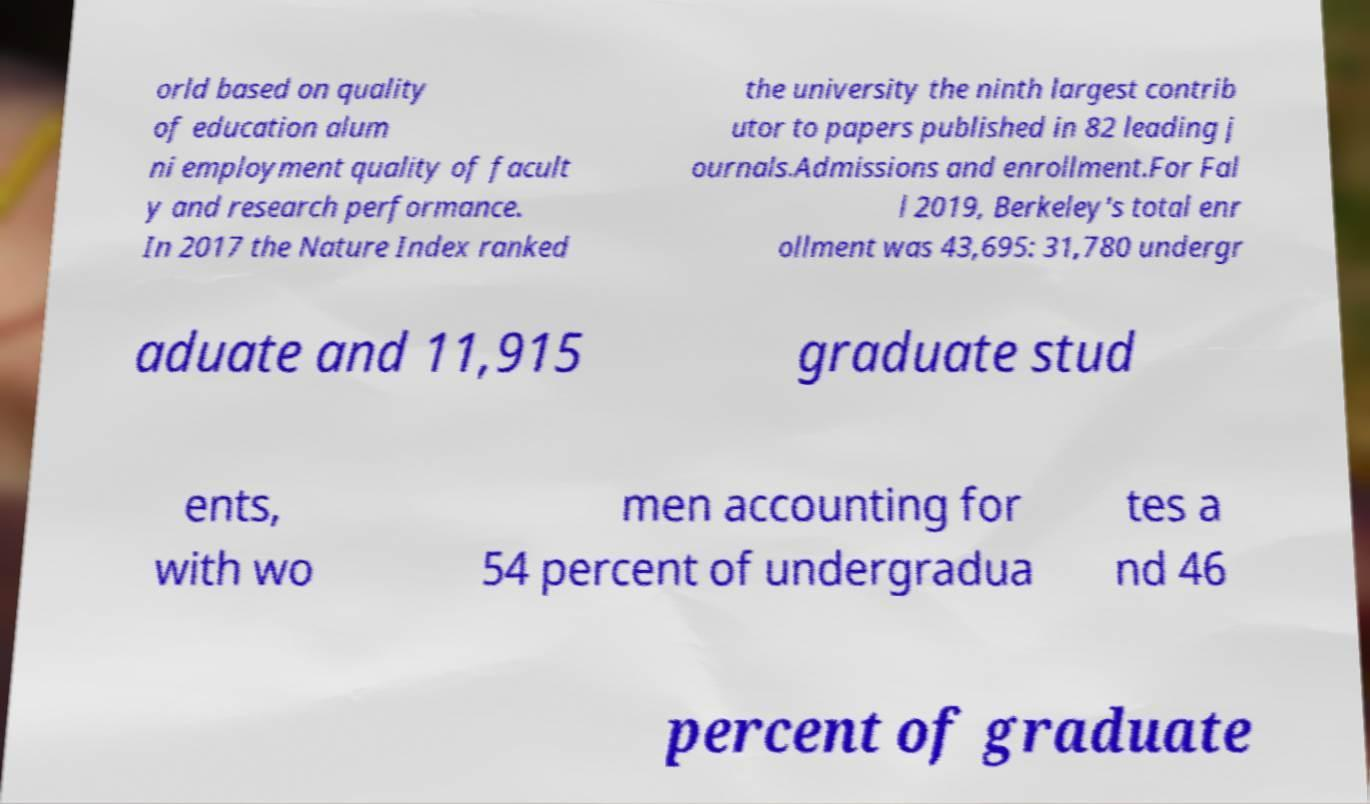There's text embedded in this image that I need extracted. Can you transcribe it verbatim? orld based on quality of education alum ni employment quality of facult y and research performance. In 2017 the Nature Index ranked the university the ninth largest contrib utor to papers published in 82 leading j ournals.Admissions and enrollment.For Fal l 2019, Berkeley's total enr ollment was 43,695: 31,780 undergr aduate and 11,915 graduate stud ents, with wo men accounting for 54 percent of undergradua tes a nd 46 percent of graduate 